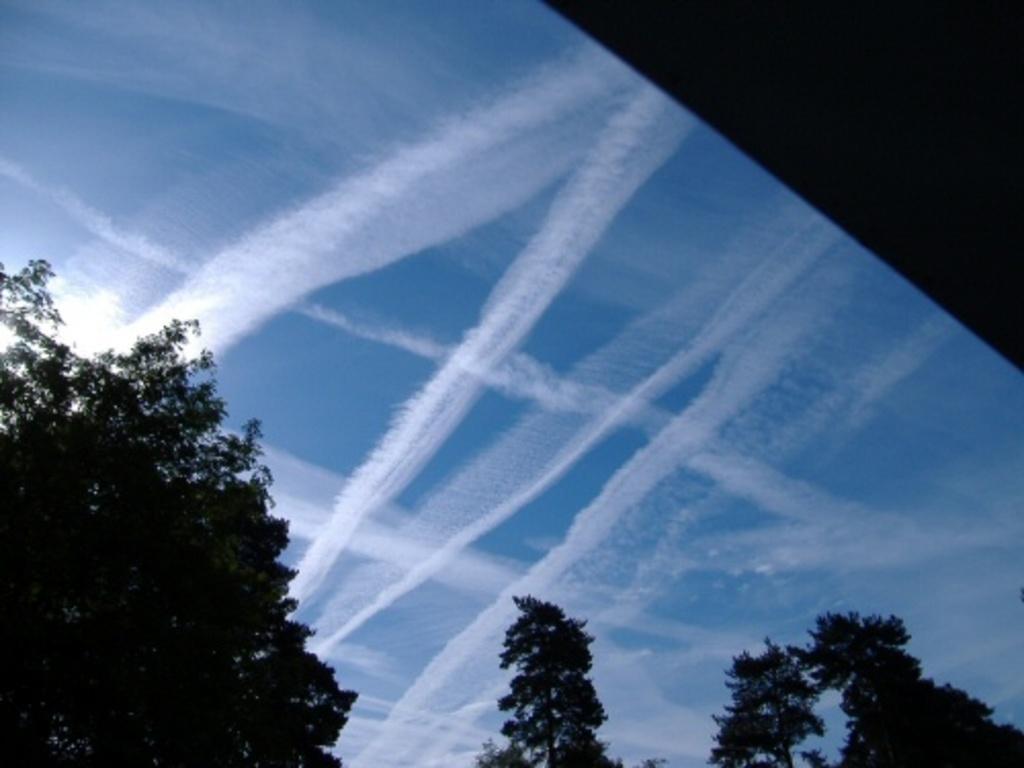Could you give a brief overview of what you see in this image? In this image we can see the clouds in the sky. There are few trees in the image. 